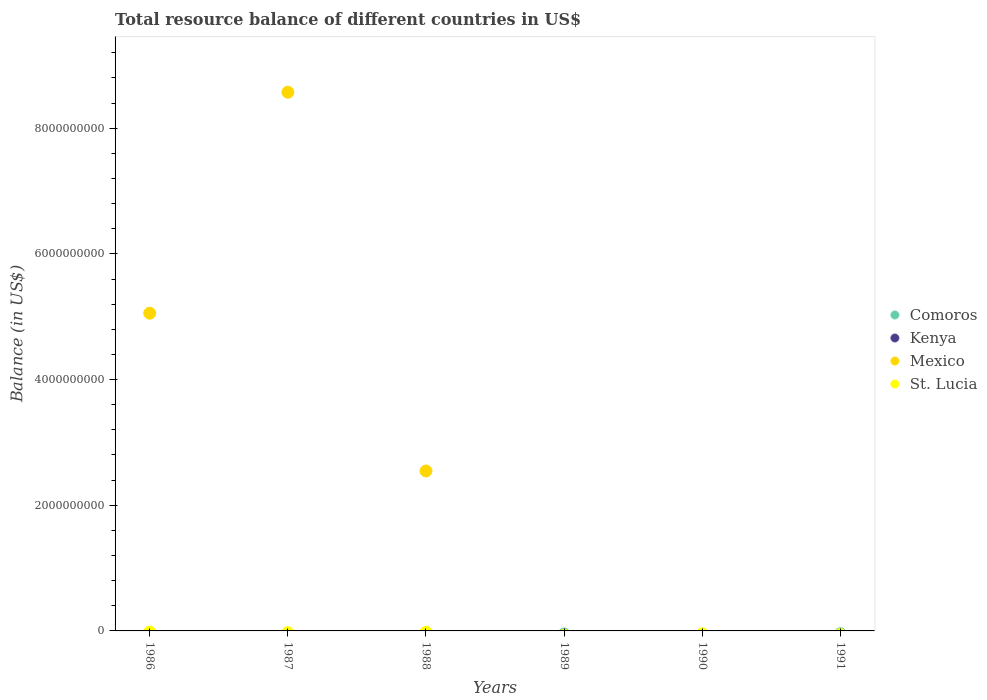How many different coloured dotlines are there?
Provide a short and direct response. 1. What is the total resource balance in St. Lucia in 1986?
Offer a very short reply. 0. Across all years, what is the minimum total resource balance in Kenya?
Provide a succinct answer. 0. What is the total total resource balance in Mexico in the graph?
Your answer should be very brief. 1.62e+1. What is the difference between the total resource balance in St. Lucia in 1991 and the total resource balance in Kenya in 1988?
Your answer should be compact. 0. What is the average total resource balance in Kenya per year?
Give a very brief answer. 0. In how many years, is the total resource balance in Kenya greater than 800000000 US$?
Provide a succinct answer. 0. What is the difference between the highest and the lowest total resource balance in Mexico?
Offer a very short reply. 8.57e+09. In how many years, is the total resource balance in Mexico greater than the average total resource balance in Mexico taken over all years?
Provide a succinct answer. 2. Is it the case that in every year, the sum of the total resource balance in St. Lucia and total resource balance in Kenya  is greater than the sum of total resource balance in Mexico and total resource balance in Comoros?
Your response must be concise. No. Is it the case that in every year, the sum of the total resource balance in St. Lucia and total resource balance in Kenya  is greater than the total resource balance in Mexico?
Make the answer very short. No. Is the total resource balance in Mexico strictly greater than the total resource balance in Kenya over the years?
Offer a very short reply. No. Is the total resource balance in Mexico strictly less than the total resource balance in Kenya over the years?
Give a very brief answer. No. How many dotlines are there?
Ensure brevity in your answer.  1. Are the values on the major ticks of Y-axis written in scientific E-notation?
Offer a terse response. No. Does the graph contain grids?
Make the answer very short. No. Where does the legend appear in the graph?
Make the answer very short. Center right. What is the title of the graph?
Give a very brief answer. Total resource balance of different countries in US$. What is the label or title of the Y-axis?
Make the answer very short. Balance (in US$). What is the Balance (in US$) in Kenya in 1986?
Offer a terse response. 0. What is the Balance (in US$) in Mexico in 1986?
Keep it short and to the point. 5.06e+09. What is the Balance (in US$) of Mexico in 1987?
Offer a terse response. 8.57e+09. What is the Balance (in US$) of St. Lucia in 1987?
Your answer should be very brief. 0. What is the Balance (in US$) in Comoros in 1988?
Your answer should be very brief. 0. What is the Balance (in US$) of Mexico in 1988?
Provide a short and direct response. 2.55e+09. What is the Balance (in US$) in Kenya in 1989?
Offer a very short reply. 0. What is the Balance (in US$) in St. Lucia in 1989?
Provide a short and direct response. 0. What is the Balance (in US$) in Kenya in 1990?
Your answer should be compact. 0. What is the Balance (in US$) of Mexico in 1990?
Your response must be concise. 0. What is the Balance (in US$) of St. Lucia in 1990?
Provide a short and direct response. 0. What is the Balance (in US$) of Mexico in 1991?
Make the answer very short. 0. What is the Balance (in US$) in St. Lucia in 1991?
Your answer should be compact. 0. Across all years, what is the maximum Balance (in US$) of Mexico?
Give a very brief answer. 8.57e+09. What is the total Balance (in US$) in Kenya in the graph?
Provide a succinct answer. 0. What is the total Balance (in US$) in Mexico in the graph?
Your answer should be very brief. 1.62e+1. What is the difference between the Balance (in US$) in Mexico in 1986 and that in 1987?
Keep it short and to the point. -3.52e+09. What is the difference between the Balance (in US$) of Mexico in 1986 and that in 1988?
Provide a succinct answer. 2.51e+09. What is the difference between the Balance (in US$) in Mexico in 1987 and that in 1988?
Offer a very short reply. 6.03e+09. What is the average Balance (in US$) of Comoros per year?
Offer a very short reply. 0. What is the average Balance (in US$) in Kenya per year?
Make the answer very short. 0. What is the average Balance (in US$) of Mexico per year?
Keep it short and to the point. 2.70e+09. What is the average Balance (in US$) of St. Lucia per year?
Provide a succinct answer. 0. What is the ratio of the Balance (in US$) of Mexico in 1986 to that in 1987?
Your answer should be compact. 0.59. What is the ratio of the Balance (in US$) in Mexico in 1986 to that in 1988?
Provide a short and direct response. 1.99. What is the ratio of the Balance (in US$) in Mexico in 1987 to that in 1988?
Keep it short and to the point. 3.37. What is the difference between the highest and the second highest Balance (in US$) in Mexico?
Your answer should be very brief. 3.52e+09. What is the difference between the highest and the lowest Balance (in US$) of Mexico?
Your answer should be compact. 8.57e+09. 